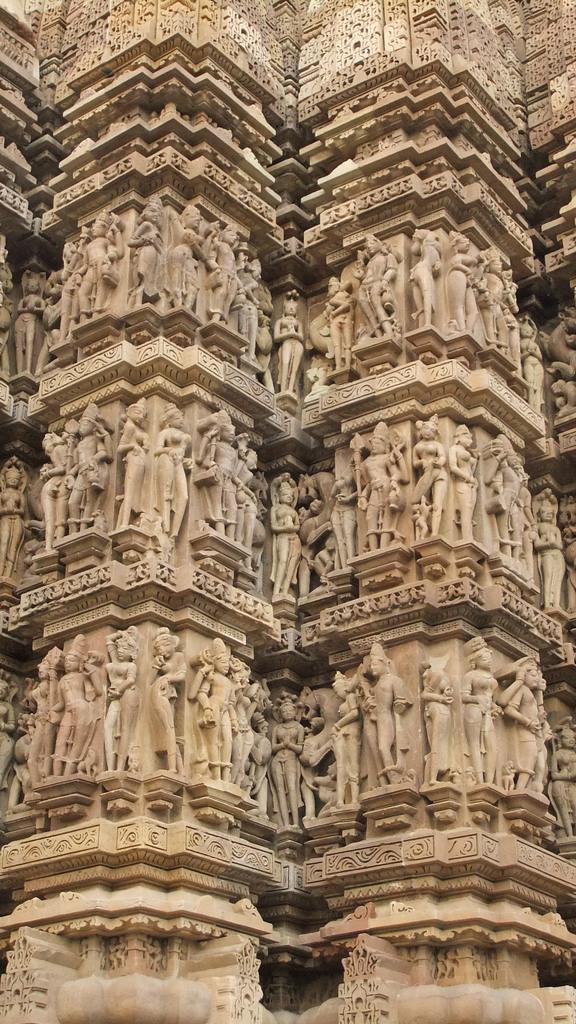In one or two sentences, can you explain what this image depicts? In this image we can see a group of sculptures carved on a stone. 